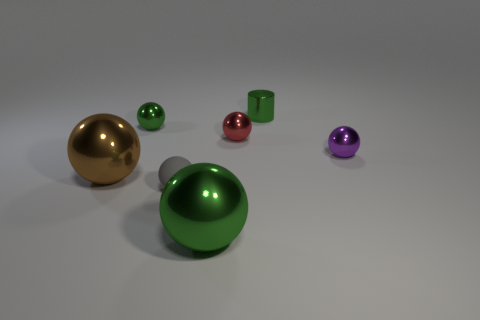Subtract all green balls. How many were subtracted if there are1green balls left? 1 Add 1 large purple rubber things. How many objects exist? 8 Subtract all gray matte spheres. How many spheres are left? 5 Subtract 6 balls. How many balls are left? 0 Subtract all brown cylinders. How many green spheres are left? 2 Subtract all brown balls. How many balls are left? 5 Subtract 0 brown cylinders. How many objects are left? 7 Subtract all balls. How many objects are left? 1 Subtract all red balls. Subtract all blue cylinders. How many balls are left? 5 Subtract all big green cylinders. Subtract all purple things. How many objects are left? 6 